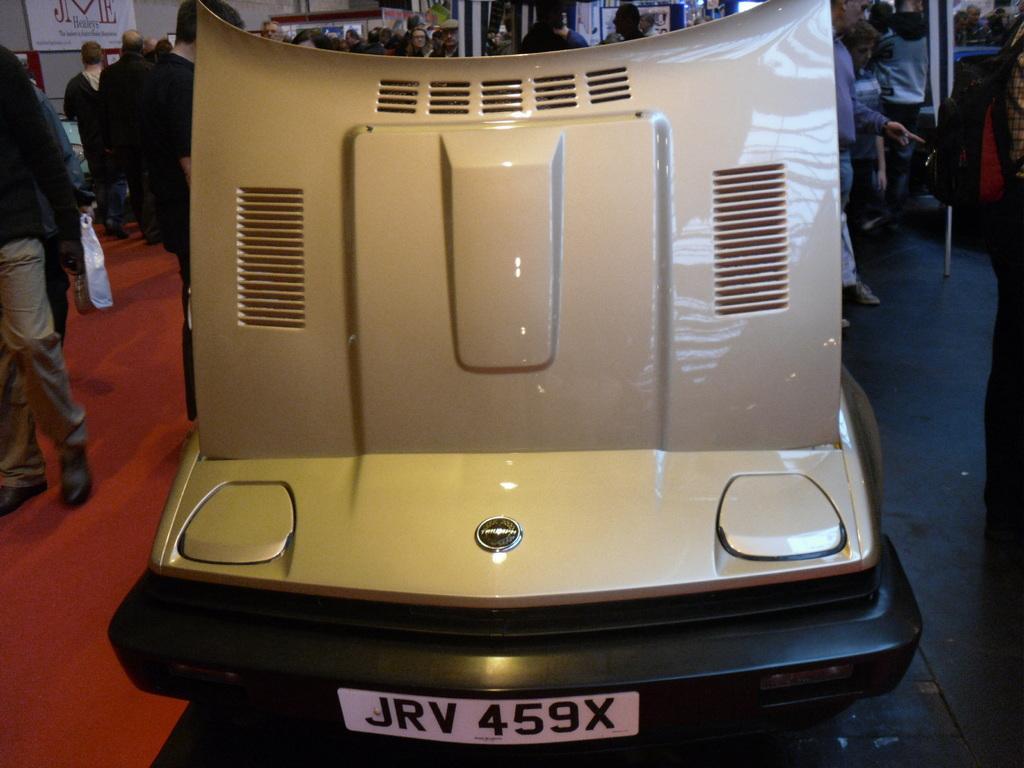Could you give a brief overview of what you see in this image? In the foreground of this image, there is a vehicle. In the background, there are persons standing and walking on the floor. We can also see few posts and the poles. 